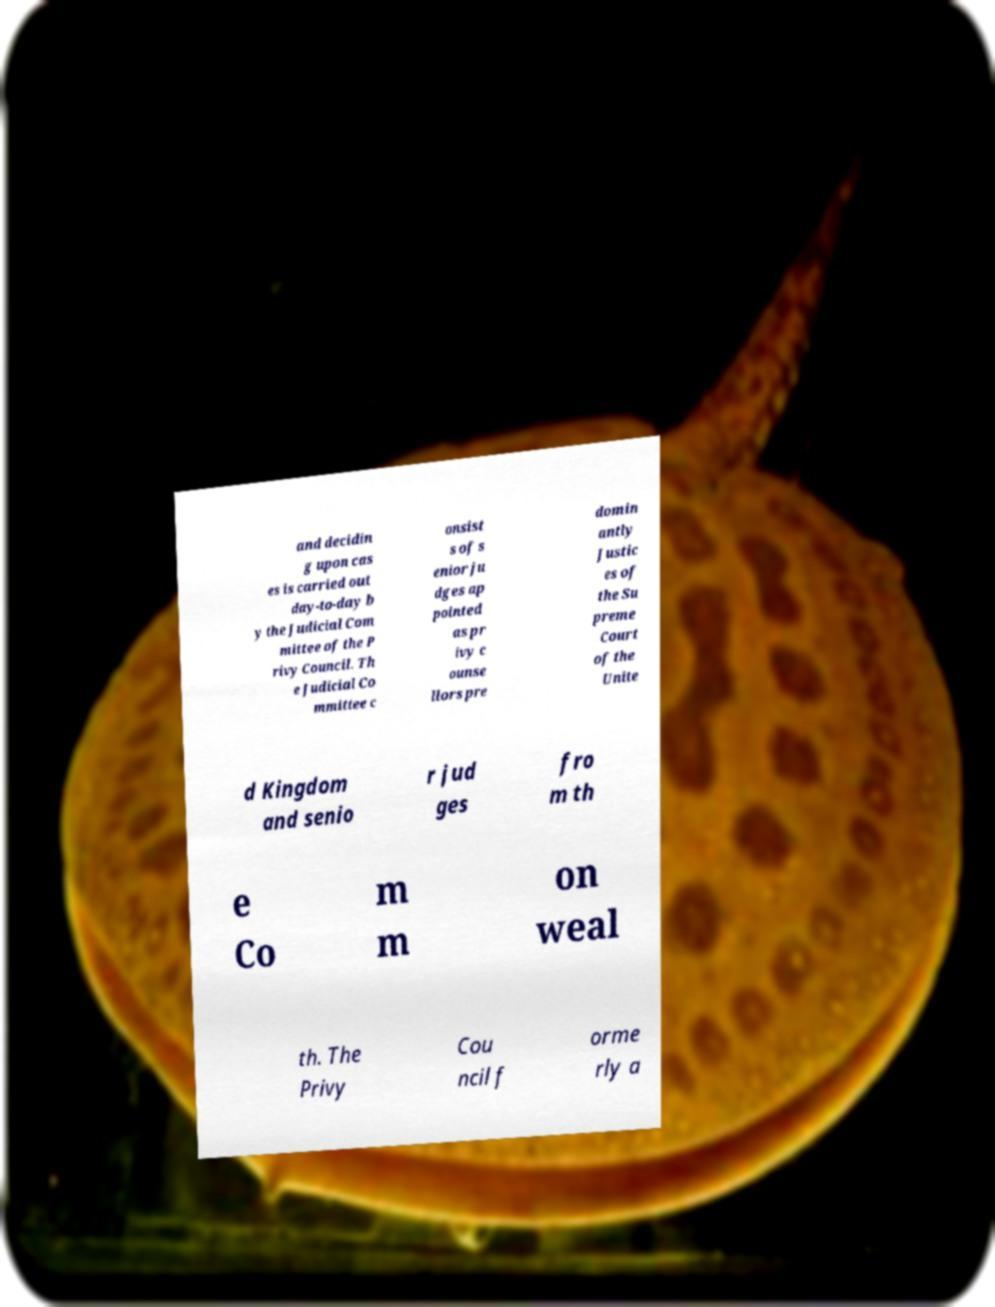What messages or text are displayed in this image? I need them in a readable, typed format. and decidin g upon cas es is carried out day-to-day b y the Judicial Com mittee of the P rivy Council. Th e Judicial Co mmittee c onsist s of s enior ju dges ap pointed as pr ivy c ounse llors pre domin antly Justic es of the Su preme Court of the Unite d Kingdom and senio r jud ges fro m th e Co m m on weal th. The Privy Cou ncil f orme rly a 